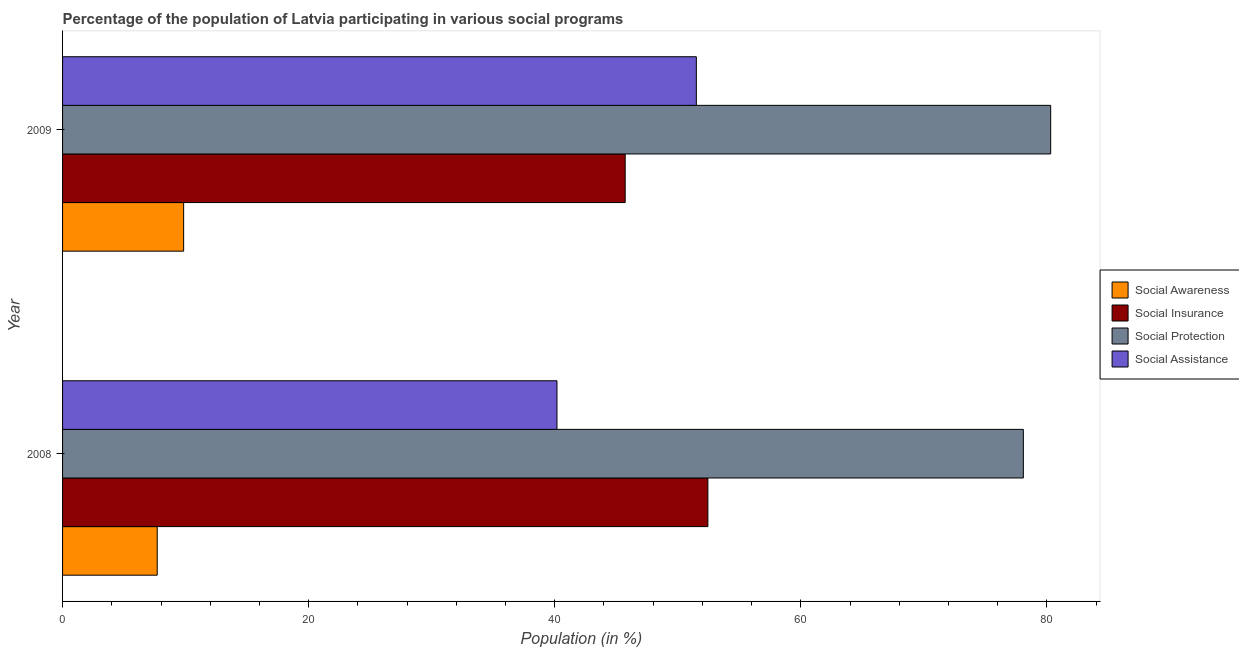Are the number of bars per tick equal to the number of legend labels?
Make the answer very short. Yes. How many bars are there on the 1st tick from the top?
Keep it short and to the point. 4. In how many cases, is the number of bars for a given year not equal to the number of legend labels?
Keep it short and to the point. 0. What is the participation of population in social protection programs in 2008?
Ensure brevity in your answer.  78.08. Across all years, what is the maximum participation of population in social insurance programs?
Your answer should be compact. 52.44. Across all years, what is the minimum participation of population in social insurance programs?
Keep it short and to the point. 45.72. What is the total participation of population in social protection programs in the graph?
Offer a terse response. 158.38. What is the difference between the participation of population in social assistance programs in 2008 and that in 2009?
Ensure brevity in your answer.  -11.33. What is the difference between the participation of population in social awareness programs in 2009 and the participation of population in social insurance programs in 2008?
Ensure brevity in your answer.  -42.6. What is the average participation of population in social protection programs per year?
Your answer should be compact. 79.19. In the year 2008, what is the difference between the participation of population in social insurance programs and participation of population in social awareness programs?
Make the answer very short. 44.75. In how many years, is the participation of population in social assistance programs greater than 48 %?
Give a very brief answer. 1. What is the ratio of the participation of population in social insurance programs in 2008 to that in 2009?
Your answer should be compact. 1.15. Is the difference between the participation of population in social awareness programs in 2008 and 2009 greater than the difference between the participation of population in social assistance programs in 2008 and 2009?
Offer a terse response. Yes. Is it the case that in every year, the sum of the participation of population in social assistance programs and participation of population in social protection programs is greater than the sum of participation of population in social awareness programs and participation of population in social insurance programs?
Give a very brief answer. Yes. What does the 1st bar from the top in 2008 represents?
Give a very brief answer. Social Assistance. What does the 4th bar from the bottom in 2009 represents?
Make the answer very short. Social Assistance. How many bars are there?
Ensure brevity in your answer.  8. How many years are there in the graph?
Your response must be concise. 2. What is the difference between two consecutive major ticks on the X-axis?
Provide a short and direct response. 20. Are the values on the major ticks of X-axis written in scientific E-notation?
Your answer should be very brief. No. Does the graph contain any zero values?
Your answer should be very brief. No. Where does the legend appear in the graph?
Keep it short and to the point. Center right. What is the title of the graph?
Your response must be concise. Percentage of the population of Latvia participating in various social programs . What is the label or title of the Y-axis?
Make the answer very short. Year. What is the Population (in %) in Social Awareness in 2008?
Give a very brief answer. 7.69. What is the Population (in %) of Social Insurance in 2008?
Make the answer very short. 52.44. What is the Population (in %) in Social Protection in 2008?
Offer a very short reply. 78.08. What is the Population (in %) in Social Assistance in 2008?
Offer a very short reply. 40.18. What is the Population (in %) in Social Awareness in 2009?
Provide a short and direct response. 9.84. What is the Population (in %) of Social Insurance in 2009?
Offer a terse response. 45.72. What is the Population (in %) of Social Protection in 2009?
Offer a terse response. 80.3. What is the Population (in %) in Social Assistance in 2009?
Offer a very short reply. 51.51. Across all years, what is the maximum Population (in %) of Social Awareness?
Keep it short and to the point. 9.84. Across all years, what is the maximum Population (in %) of Social Insurance?
Offer a terse response. 52.44. Across all years, what is the maximum Population (in %) of Social Protection?
Your response must be concise. 80.3. Across all years, what is the maximum Population (in %) of Social Assistance?
Keep it short and to the point. 51.51. Across all years, what is the minimum Population (in %) in Social Awareness?
Ensure brevity in your answer.  7.69. Across all years, what is the minimum Population (in %) of Social Insurance?
Provide a succinct answer. 45.72. Across all years, what is the minimum Population (in %) in Social Protection?
Keep it short and to the point. 78.08. Across all years, what is the minimum Population (in %) in Social Assistance?
Offer a terse response. 40.18. What is the total Population (in %) in Social Awareness in the graph?
Keep it short and to the point. 17.53. What is the total Population (in %) in Social Insurance in the graph?
Ensure brevity in your answer.  98.17. What is the total Population (in %) in Social Protection in the graph?
Your response must be concise. 158.38. What is the total Population (in %) of Social Assistance in the graph?
Provide a short and direct response. 91.69. What is the difference between the Population (in %) of Social Awareness in 2008 and that in 2009?
Your response must be concise. -2.15. What is the difference between the Population (in %) in Social Insurance in 2008 and that in 2009?
Offer a very short reply. 6.72. What is the difference between the Population (in %) of Social Protection in 2008 and that in 2009?
Provide a short and direct response. -2.22. What is the difference between the Population (in %) of Social Assistance in 2008 and that in 2009?
Your answer should be very brief. -11.33. What is the difference between the Population (in %) in Social Awareness in 2008 and the Population (in %) in Social Insurance in 2009?
Ensure brevity in your answer.  -38.03. What is the difference between the Population (in %) of Social Awareness in 2008 and the Population (in %) of Social Protection in 2009?
Make the answer very short. -72.61. What is the difference between the Population (in %) of Social Awareness in 2008 and the Population (in %) of Social Assistance in 2009?
Offer a terse response. -43.81. What is the difference between the Population (in %) in Social Insurance in 2008 and the Population (in %) in Social Protection in 2009?
Provide a succinct answer. -27.86. What is the difference between the Population (in %) in Social Insurance in 2008 and the Population (in %) in Social Assistance in 2009?
Offer a terse response. 0.94. What is the difference between the Population (in %) of Social Protection in 2008 and the Population (in %) of Social Assistance in 2009?
Offer a terse response. 26.57. What is the average Population (in %) of Social Awareness per year?
Offer a very short reply. 8.77. What is the average Population (in %) in Social Insurance per year?
Provide a short and direct response. 49.08. What is the average Population (in %) in Social Protection per year?
Provide a succinct answer. 79.19. What is the average Population (in %) in Social Assistance per year?
Provide a succinct answer. 45.84. In the year 2008, what is the difference between the Population (in %) in Social Awareness and Population (in %) in Social Insurance?
Your response must be concise. -44.75. In the year 2008, what is the difference between the Population (in %) of Social Awareness and Population (in %) of Social Protection?
Give a very brief answer. -70.39. In the year 2008, what is the difference between the Population (in %) in Social Awareness and Population (in %) in Social Assistance?
Your answer should be very brief. -32.49. In the year 2008, what is the difference between the Population (in %) in Social Insurance and Population (in %) in Social Protection?
Ensure brevity in your answer.  -25.64. In the year 2008, what is the difference between the Population (in %) of Social Insurance and Population (in %) of Social Assistance?
Offer a terse response. 12.26. In the year 2008, what is the difference between the Population (in %) in Social Protection and Population (in %) in Social Assistance?
Your answer should be compact. 37.9. In the year 2009, what is the difference between the Population (in %) in Social Awareness and Population (in %) in Social Insurance?
Your response must be concise. -35.88. In the year 2009, what is the difference between the Population (in %) in Social Awareness and Population (in %) in Social Protection?
Keep it short and to the point. -70.46. In the year 2009, what is the difference between the Population (in %) of Social Awareness and Population (in %) of Social Assistance?
Offer a terse response. -41.67. In the year 2009, what is the difference between the Population (in %) in Social Insurance and Population (in %) in Social Protection?
Provide a short and direct response. -34.58. In the year 2009, what is the difference between the Population (in %) of Social Insurance and Population (in %) of Social Assistance?
Make the answer very short. -5.78. In the year 2009, what is the difference between the Population (in %) in Social Protection and Population (in %) in Social Assistance?
Keep it short and to the point. 28.8. What is the ratio of the Population (in %) in Social Awareness in 2008 to that in 2009?
Your answer should be very brief. 0.78. What is the ratio of the Population (in %) of Social Insurance in 2008 to that in 2009?
Offer a terse response. 1.15. What is the ratio of the Population (in %) in Social Protection in 2008 to that in 2009?
Your answer should be compact. 0.97. What is the ratio of the Population (in %) of Social Assistance in 2008 to that in 2009?
Give a very brief answer. 0.78. What is the difference between the highest and the second highest Population (in %) of Social Awareness?
Offer a terse response. 2.15. What is the difference between the highest and the second highest Population (in %) in Social Insurance?
Your answer should be very brief. 6.72. What is the difference between the highest and the second highest Population (in %) in Social Protection?
Your response must be concise. 2.22. What is the difference between the highest and the second highest Population (in %) in Social Assistance?
Offer a very short reply. 11.33. What is the difference between the highest and the lowest Population (in %) in Social Awareness?
Give a very brief answer. 2.15. What is the difference between the highest and the lowest Population (in %) in Social Insurance?
Offer a terse response. 6.72. What is the difference between the highest and the lowest Population (in %) in Social Protection?
Keep it short and to the point. 2.22. What is the difference between the highest and the lowest Population (in %) of Social Assistance?
Make the answer very short. 11.33. 